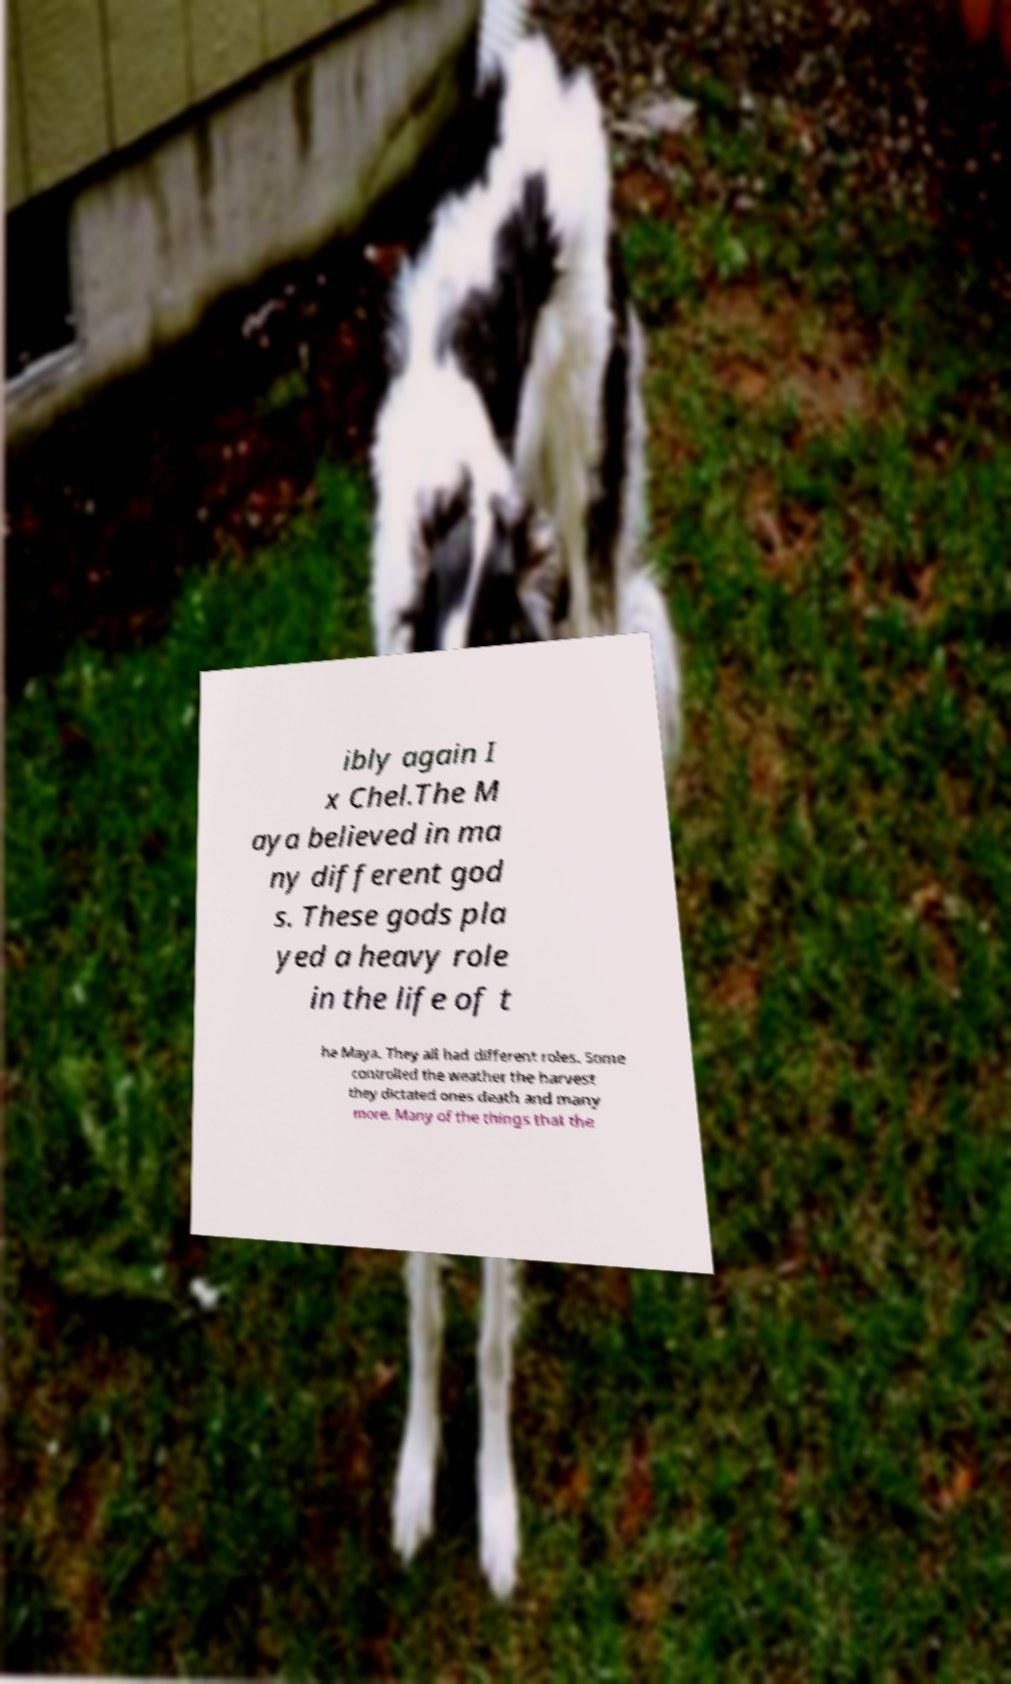Please identify and transcribe the text found in this image. ibly again I x Chel.The M aya believed in ma ny different god s. These gods pla yed a heavy role in the life of t he Maya. They all had different roles. Some controlled the weather the harvest they dictated ones death and many more. Many of the things that the 